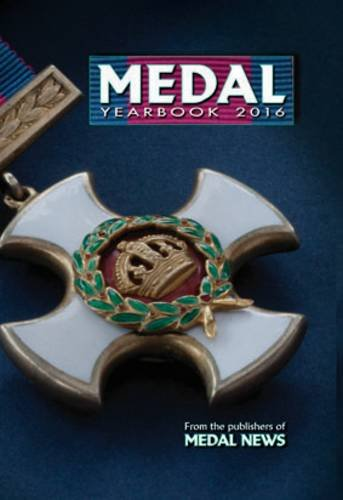Can you tell me more about the medal displayed on the cover of the 'Medal Yearbook 2016'? The medal on the cover appears to be a decorative award with a cross design, featuring a central emblem and green enamel detailing, likely of significant historical value and interest to collectors. 